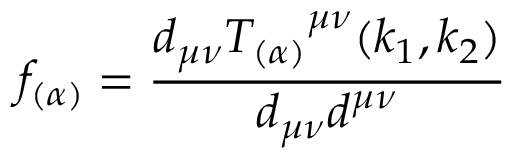Convert formula to latex. <formula><loc_0><loc_0><loc_500><loc_500>f _ { ( \alpha ) } = \frac { d _ { \mu \nu } { T _ { ( \alpha ) } } ^ { \mu \nu } ( k _ { 1 } , k _ { 2 } ) } { d _ { \mu \nu } d ^ { \mu \nu } }</formula> 